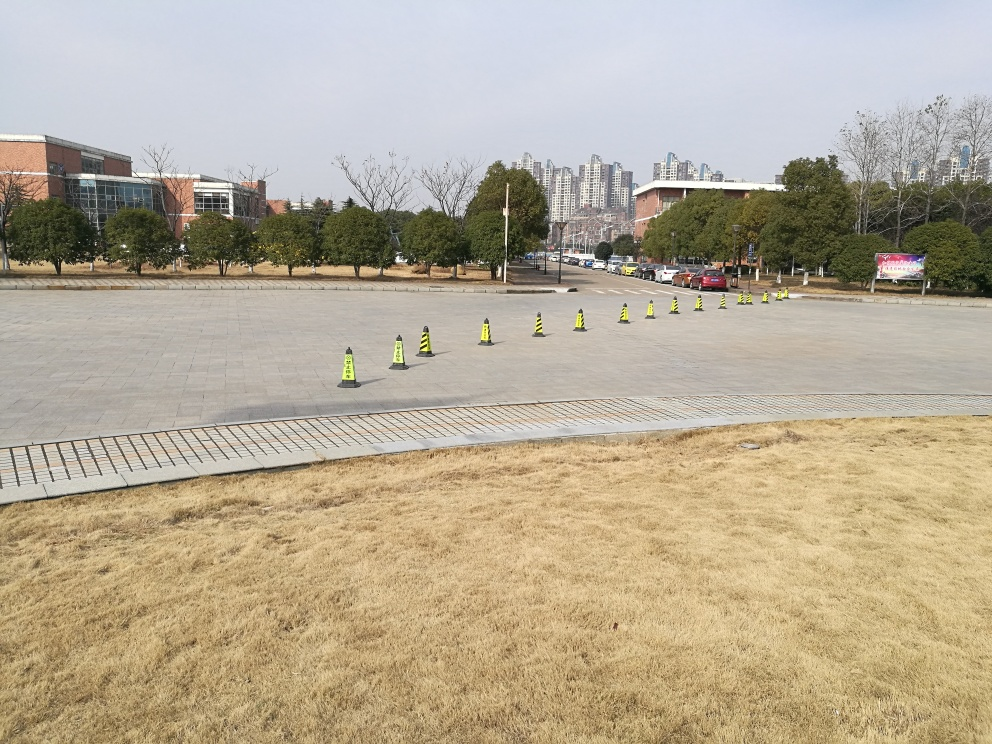What else can you observe about the area that isn't immediately obvious? There is a subtle but notable transition from the paved surface to the grassy edge, which reflects an interesting interplay between the urban space and the natural environment. Additionally, the presence of vehicles in the background suggests a roadway nearby, indicating that this area serves multiple purposes and accommodates various types of traffic. 